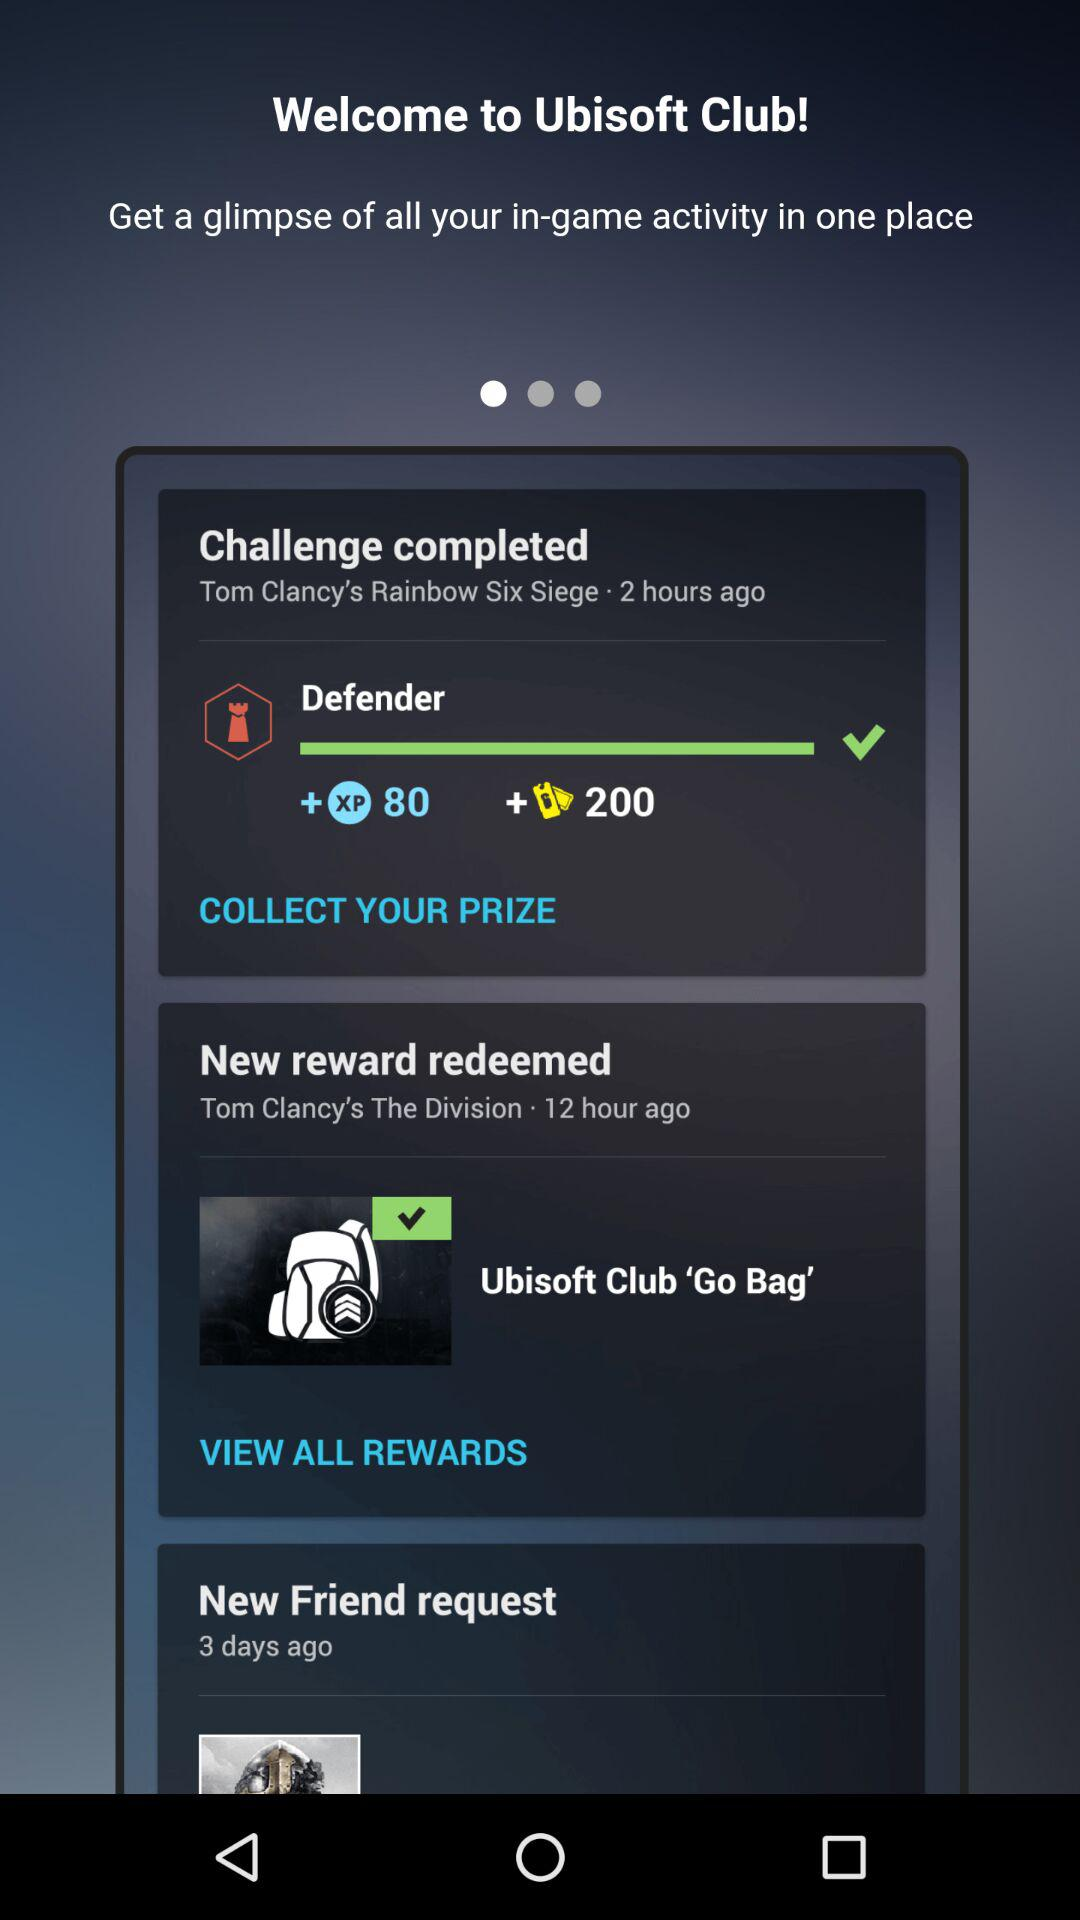How many hours ago was the last challenge completed?
Answer the question using a single word or phrase. 2 